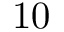<formula> <loc_0><loc_0><loc_500><loc_500>1 0</formula> 